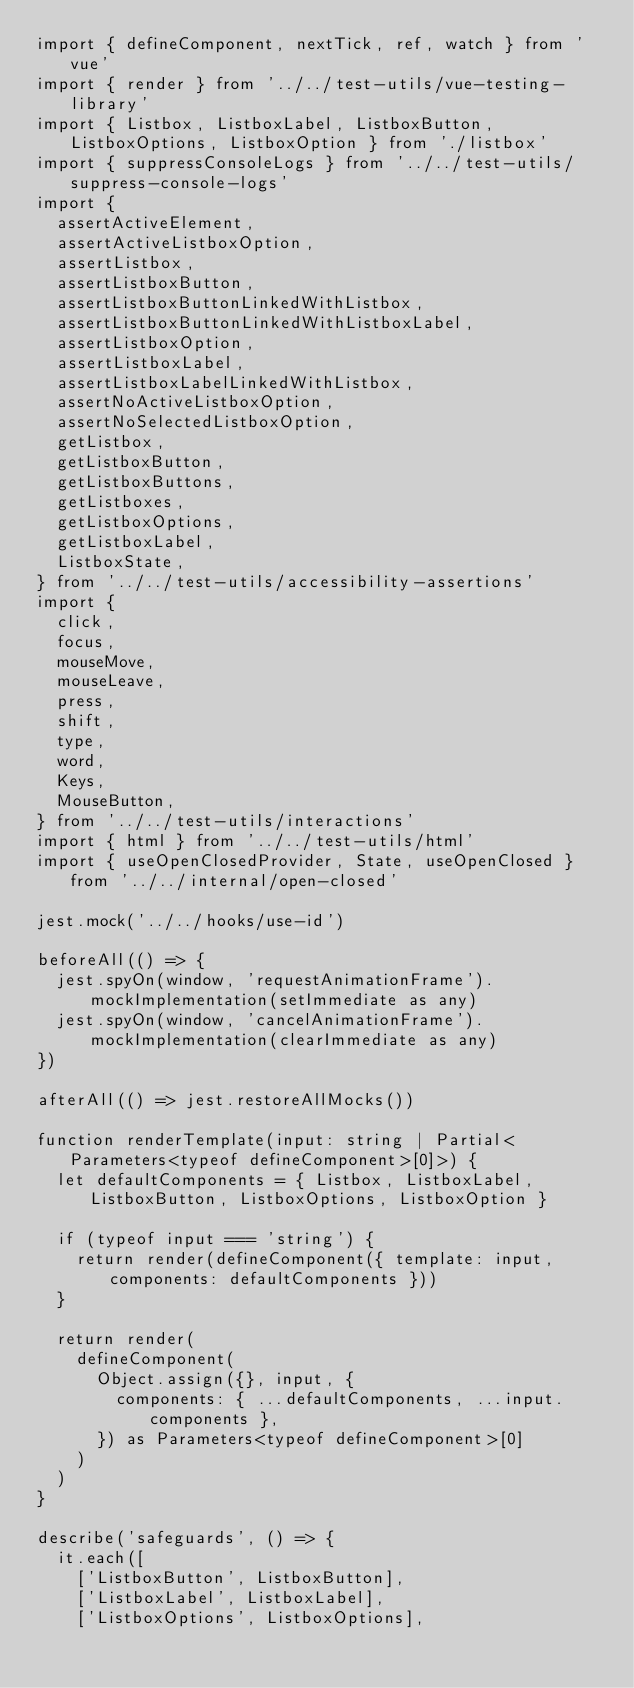<code> <loc_0><loc_0><loc_500><loc_500><_TypeScript_>import { defineComponent, nextTick, ref, watch } from 'vue'
import { render } from '../../test-utils/vue-testing-library'
import { Listbox, ListboxLabel, ListboxButton, ListboxOptions, ListboxOption } from './listbox'
import { suppressConsoleLogs } from '../../test-utils/suppress-console-logs'
import {
  assertActiveElement,
  assertActiveListboxOption,
  assertListbox,
  assertListboxButton,
  assertListboxButtonLinkedWithListbox,
  assertListboxButtonLinkedWithListboxLabel,
  assertListboxOption,
  assertListboxLabel,
  assertListboxLabelLinkedWithListbox,
  assertNoActiveListboxOption,
  assertNoSelectedListboxOption,
  getListbox,
  getListboxButton,
  getListboxButtons,
  getListboxes,
  getListboxOptions,
  getListboxLabel,
  ListboxState,
} from '../../test-utils/accessibility-assertions'
import {
  click,
  focus,
  mouseMove,
  mouseLeave,
  press,
  shift,
  type,
  word,
  Keys,
  MouseButton,
} from '../../test-utils/interactions'
import { html } from '../../test-utils/html'
import { useOpenClosedProvider, State, useOpenClosed } from '../../internal/open-closed'

jest.mock('../../hooks/use-id')

beforeAll(() => {
  jest.spyOn(window, 'requestAnimationFrame').mockImplementation(setImmediate as any)
  jest.spyOn(window, 'cancelAnimationFrame').mockImplementation(clearImmediate as any)
})

afterAll(() => jest.restoreAllMocks())

function renderTemplate(input: string | Partial<Parameters<typeof defineComponent>[0]>) {
  let defaultComponents = { Listbox, ListboxLabel, ListboxButton, ListboxOptions, ListboxOption }

  if (typeof input === 'string') {
    return render(defineComponent({ template: input, components: defaultComponents }))
  }

  return render(
    defineComponent(
      Object.assign({}, input, {
        components: { ...defaultComponents, ...input.components },
      }) as Parameters<typeof defineComponent>[0]
    )
  )
}

describe('safeguards', () => {
  it.each([
    ['ListboxButton', ListboxButton],
    ['ListboxLabel', ListboxLabel],
    ['ListboxOptions', ListboxOptions],</code> 